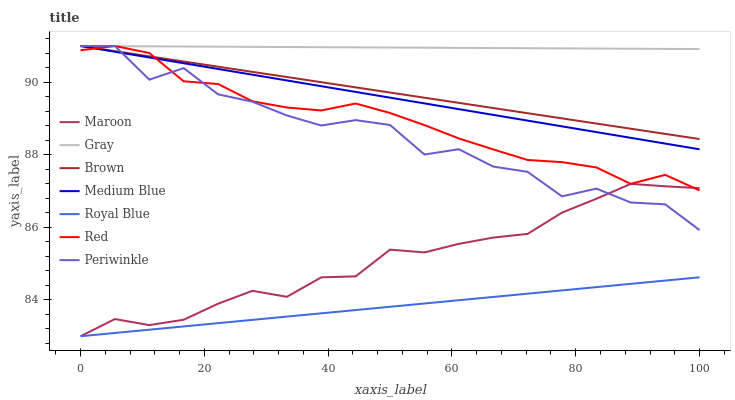Does Royal Blue have the minimum area under the curve?
Answer yes or no. Yes. Does Gray have the maximum area under the curve?
Answer yes or no. Yes. Does Brown have the minimum area under the curve?
Answer yes or no. No. Does Brown have the maximum area under the curve?
Answer yes or no. No. Is Gray the smoothest?
Answer yes or no. Yes. Is Periwinkle the roughest?
Answer yes or no. Yes. Is Brown the smoothest?
Answer yes or no. No. Is Brown the roughest?
Answer yes or no. No. Does Maroon have the lowest value?
Answer yes or no. Yes. Does Brown have the lowest value?
Answer yes or no. No. Does Red have the highest value?
Answer yes or no. Yes. Does Maroon have the highest value?
Answer yes or no. No. Is Royal Blue less than Periwinkle?
Answer yes or no. Yes. Is Gray greater than Royal Blue?
Answer yes or no. Yes. Does Red intersect Gray?
Answer yes or no. Yes. Is Red less than Gray?
Answer yes or no. No. Is Red greater than Gray?
Answer yes or no. No. Does Royal Blue intersect Periwinkle?
Answer yes or no. No. 